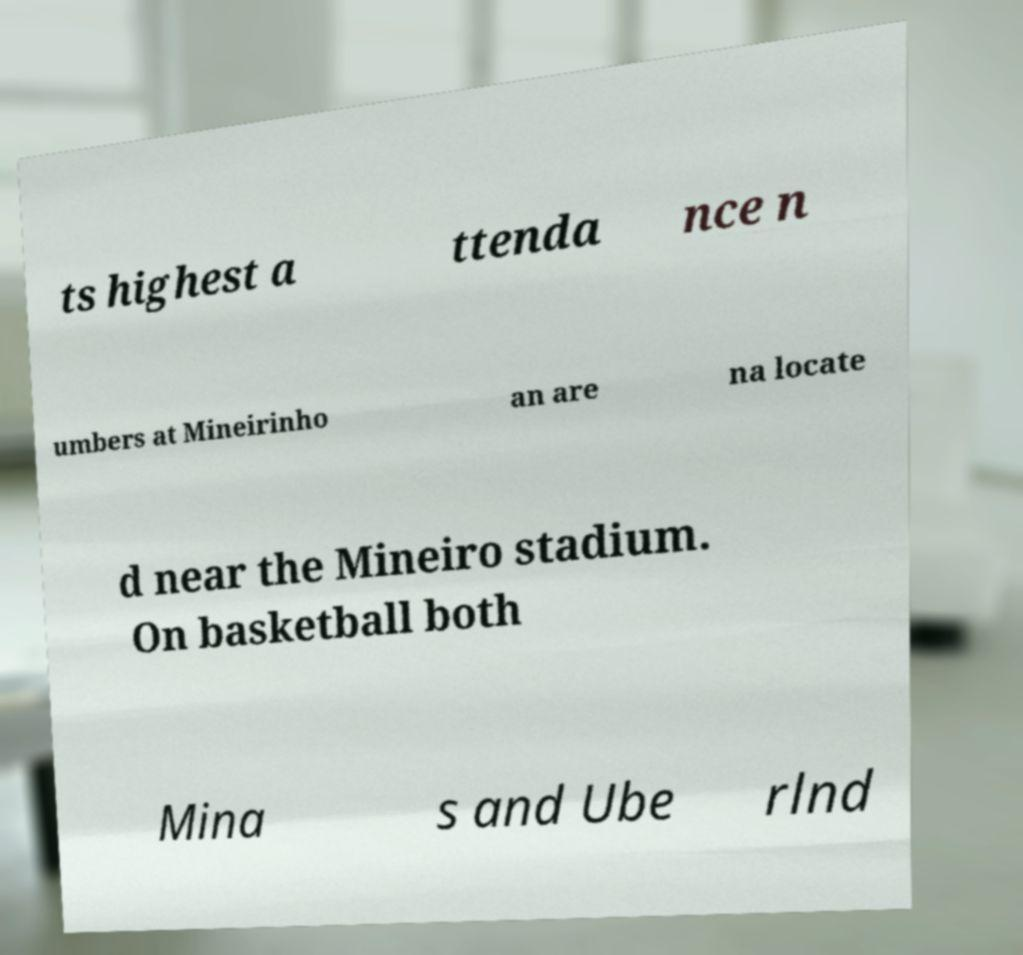What messages or text are displayed in this image? I need them in a readable, typed format. ts highest a ttenda nce n umbers at Mineirinho an are na locate d near the Mineiro stadium. On basketball both Mina s and Ube rlnd 